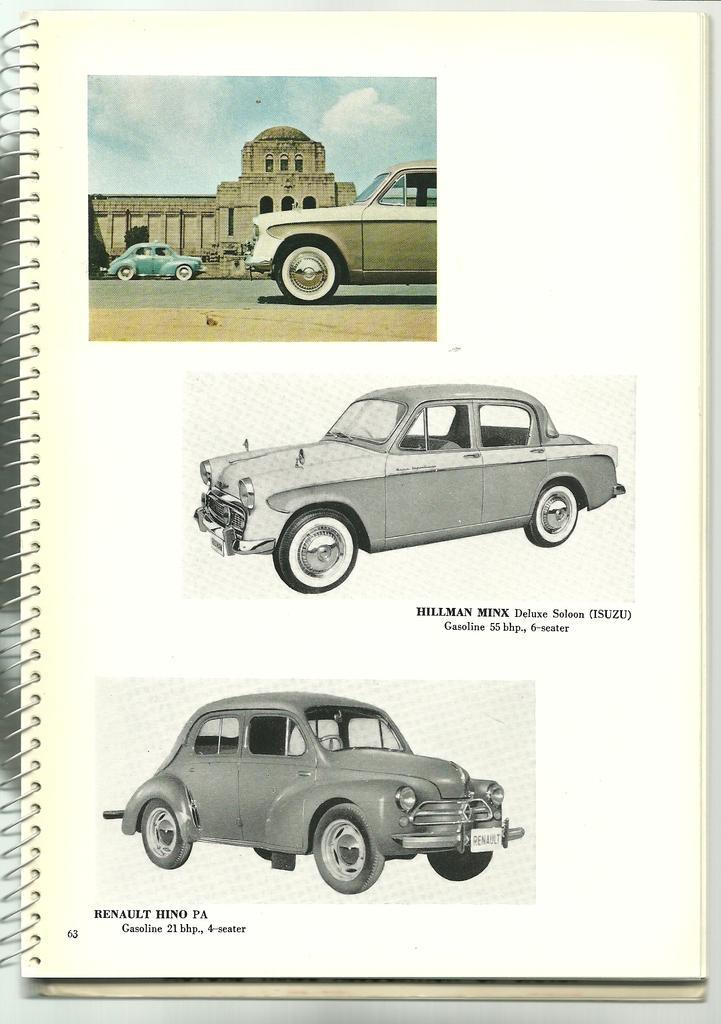How would you summarize this image in a sentence or two? There are three images of a car on a paper. 